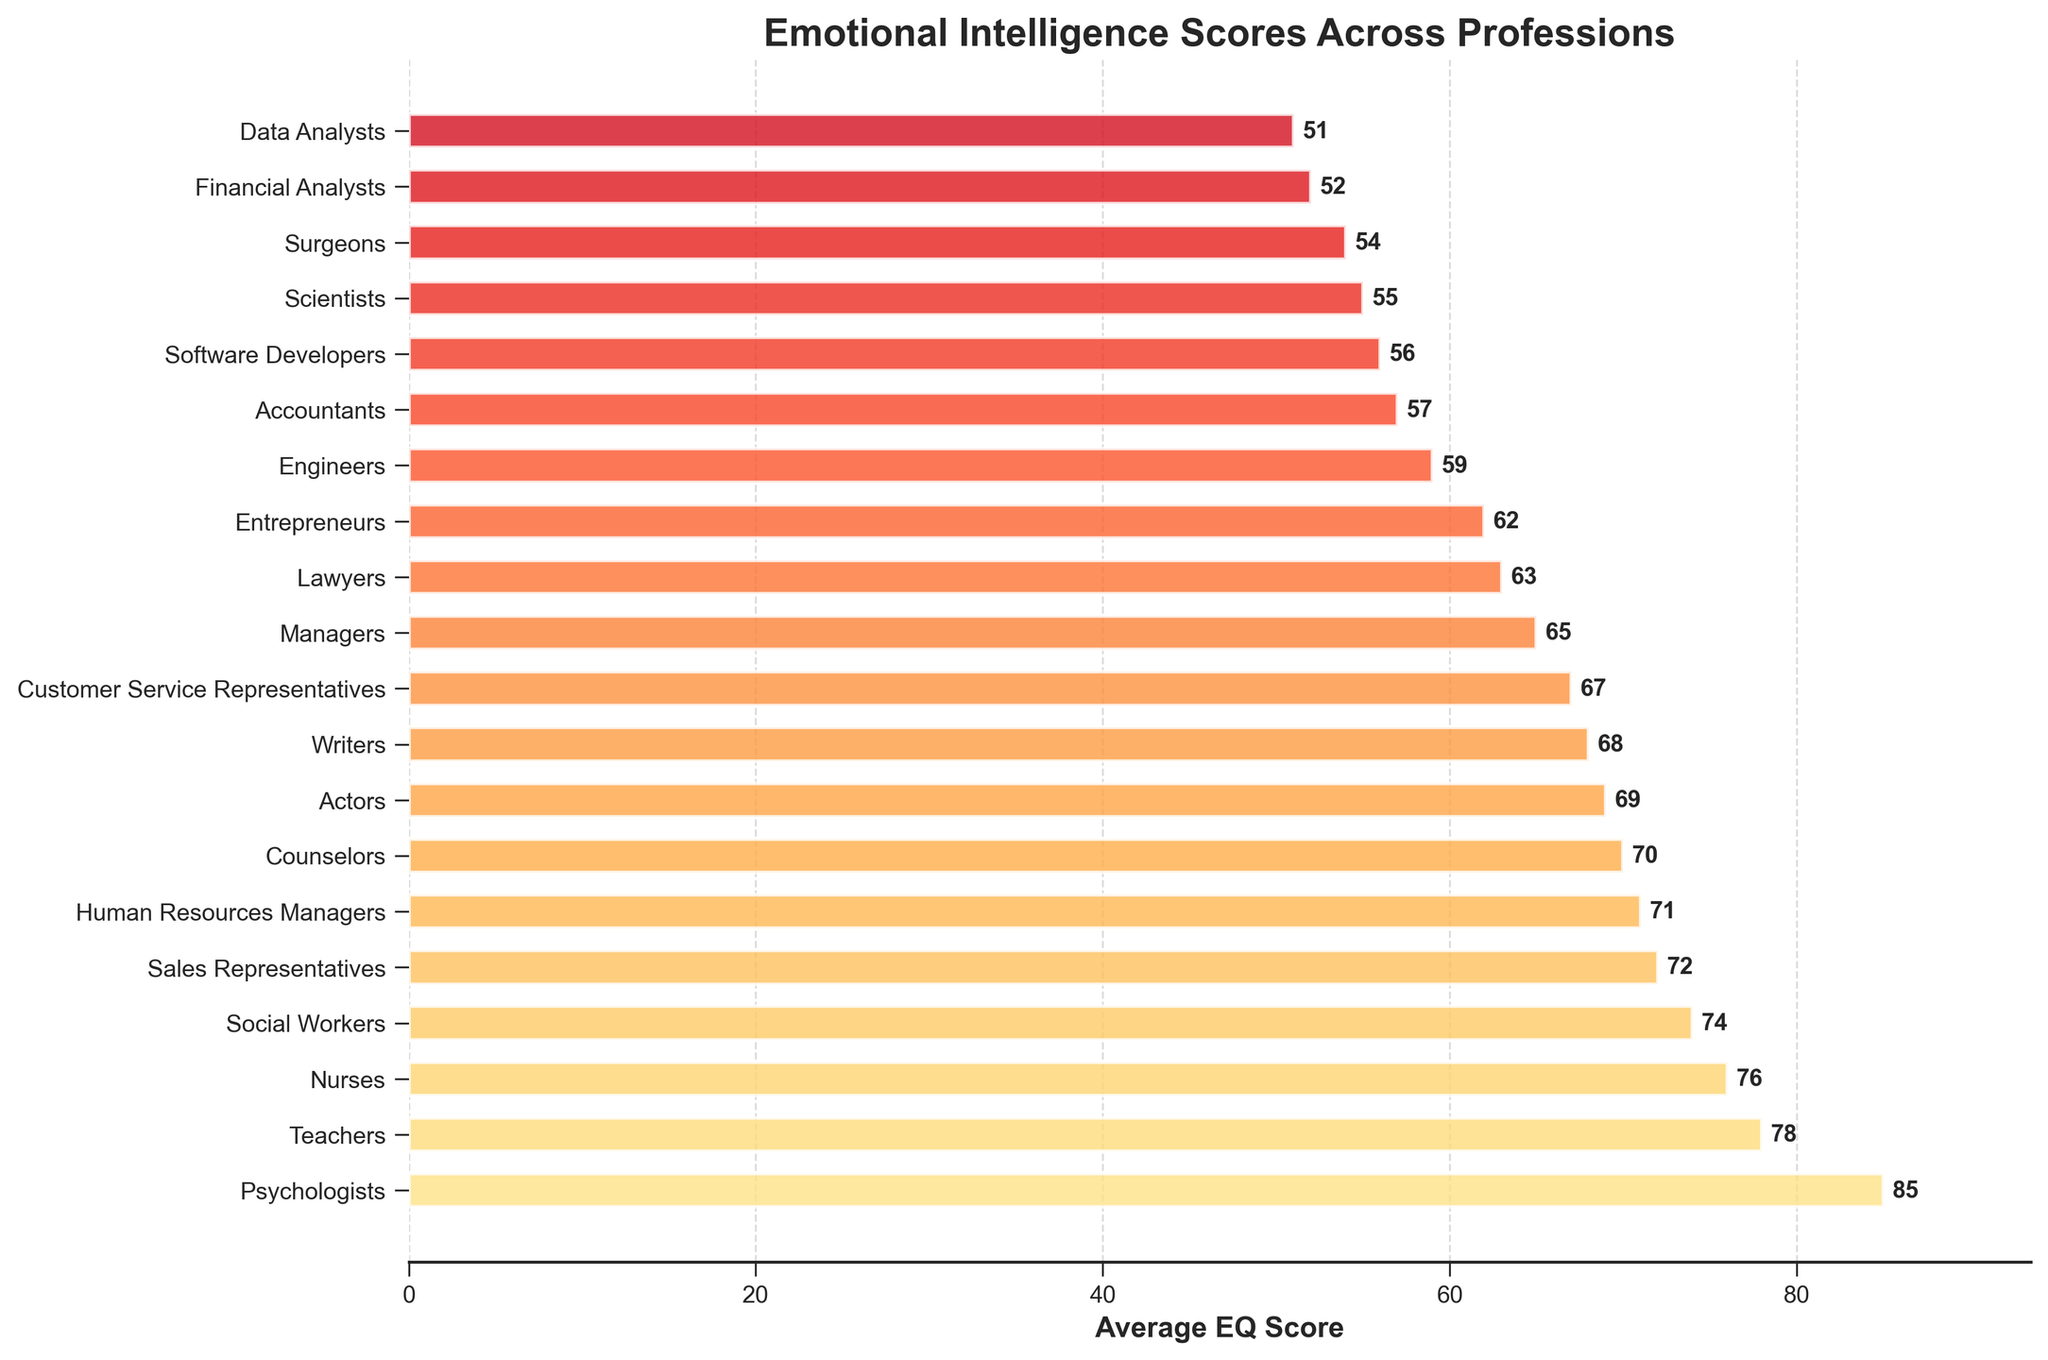Which profession has the highest EQ score? The profession with the highest bar represents the highest EQ score.
Answer: Psychologists Which profession has the lowest EQ score? The profession with the smallest bar represents the lowest EQ score.
Answer: Data Analysts How many professions have an EQ score above 70? Count the number of bars with values above 70.
Answer: 6 What is the difference in EQ scores between Psychologists and Data Analysts? Subtract the EQ score of Data Analysts from the EQ score of Psychologists: 85 - 51.
Answer: 34 Which has a higher EQ score, Nurses or Engineers? Compare the lengths of the bars for Nurses and Engineers.
Answer: Nurses Rank the top three professions by EQ score. Check the three longest bars and note the professions they represent.
Answer: Psychologists, Teachers, Nurses How much lower is the EQ score of Software Developers compared to Human Resources Managers? Subtract the EQ score of Software Developers from that of Human Resources Managers: 71 - 56.
Answer: 15 Compare the EQ scores of Actors and Writers. Which is higher? Compare the lengths of the bars for Actors and Writers to see which is longer.
Answer: Actors What is the average EQ score of Social Workers and Financial Analysts? Add the EQ scores of Social Workers (74) and Financial Analysts (52), then divide by 2: (74 + 52) / 2.
Answer: 63 Are there more professions with EQ scores below 60 or above 80? Count the bars below 60 and those above 80 and compare the counts.
Answer: Below 60 